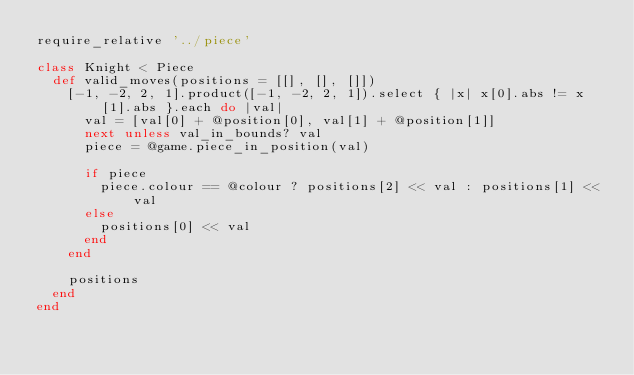Convert code to text. <code><loc_0><loc_0><loc_500><loc_500><_Ruby_>require_relative '../piece'

class Knight < Piece
  def valid_moves(positions = [[], [], []])
    [-1, -2, 2, 1].product([-1, -2, 2, 1]).select { |x| x[0].abs != x[1].abs }.each do |val|
      val = [val[0] + @position[0], val[1] + @position[1]]
      next unless val_in_bounds? val
      piece = @game.piece_in_position(val)

      if piece
        piece.colour == @colour ? positions[2] << val : positions[1] << val
      else
        positions[0] << val
      end
    end

    positions
  end
end
</code> 